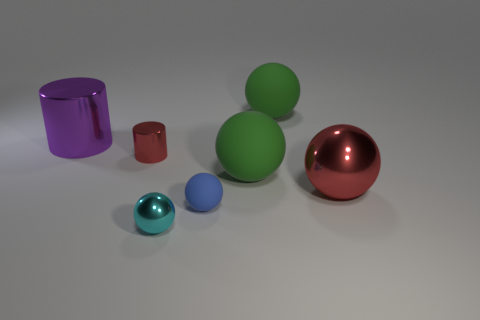There is a cylinder that is the same material as the small red thing; what is its color? The cylinder shares the same shiny, metallic quality as the small red object, which suggests they are made of a similar material. Its color is a deep, reflective purple. 